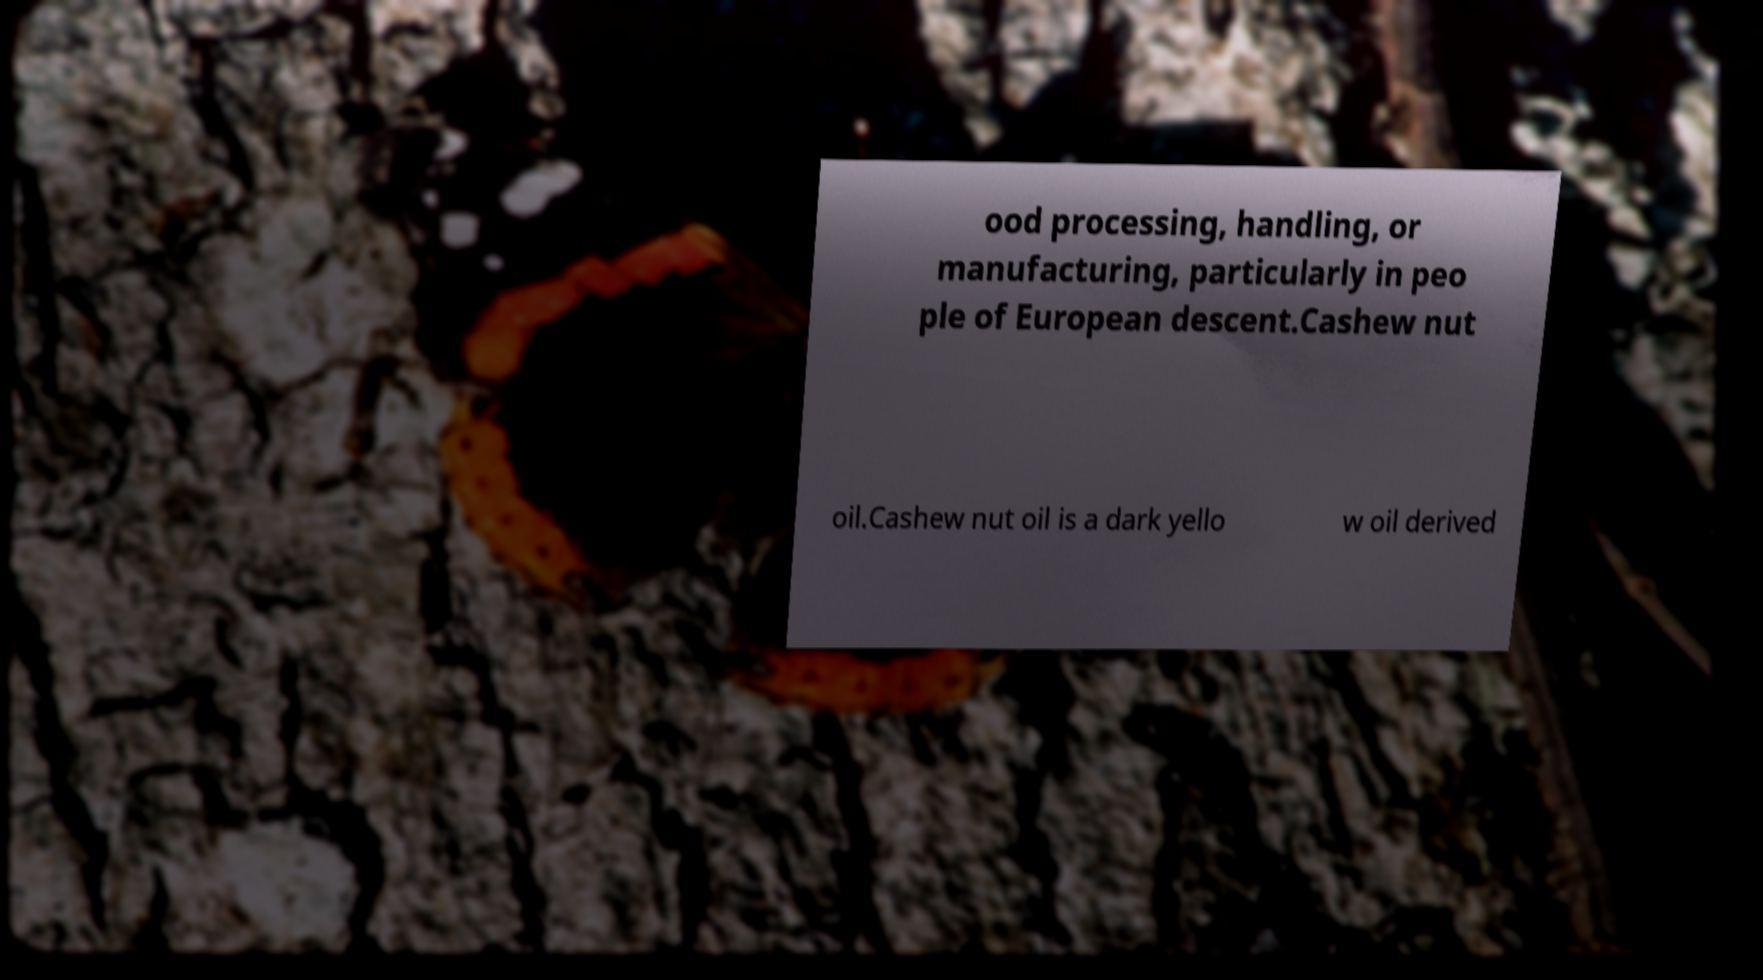Could you assist in decoding the text presented in this image and type it out clearly? ood processing, handling, or manufacturing, particularly in peo ple of European descent.Cashew nut oil.Cashew nut oil is a dark yello w oil derived 